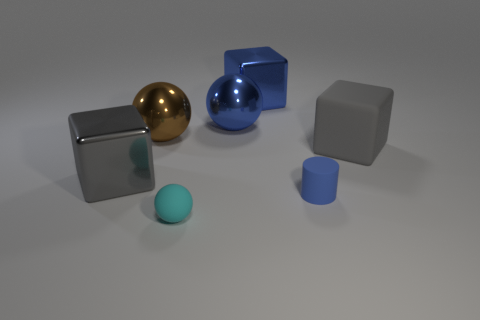There is a big gray thing right of the big blue cube; what is it made of?
Your response must be concise. Rubber. Do the cyan matte object and the blue sphere have the same size?
Provide a short and direct response. No. Are there more gray things that are behind the brown metallic object than purple objects?
Your answer should be very brief. No. There is a blue object that is the same material as the blue block; what is its size?
Provide a succinct answer. Large. Are there any small cyan things on the right side of the small matte sphere?
Provide a succinct answer. No. Does the big gray shiny object have the same shape as the gray rubber thing?
Your answer should be very brief. Yes. There is a gray block that is to the right of the large blue shiny object on the right side of the large ball right of the tiny cyan matte ball; what size is it?
Give a very brief answer. Large. What material is the big blue sphere?
Provide a short and direct response. Metal. What is the size of the metal ball that is the same color as the cylinder?
Provide a succinct answer. Large. Does the large gray matte thing have the same shape as the big blue metal thing on the right side of the blue sphere?
Offer a very short reply. Yes. 